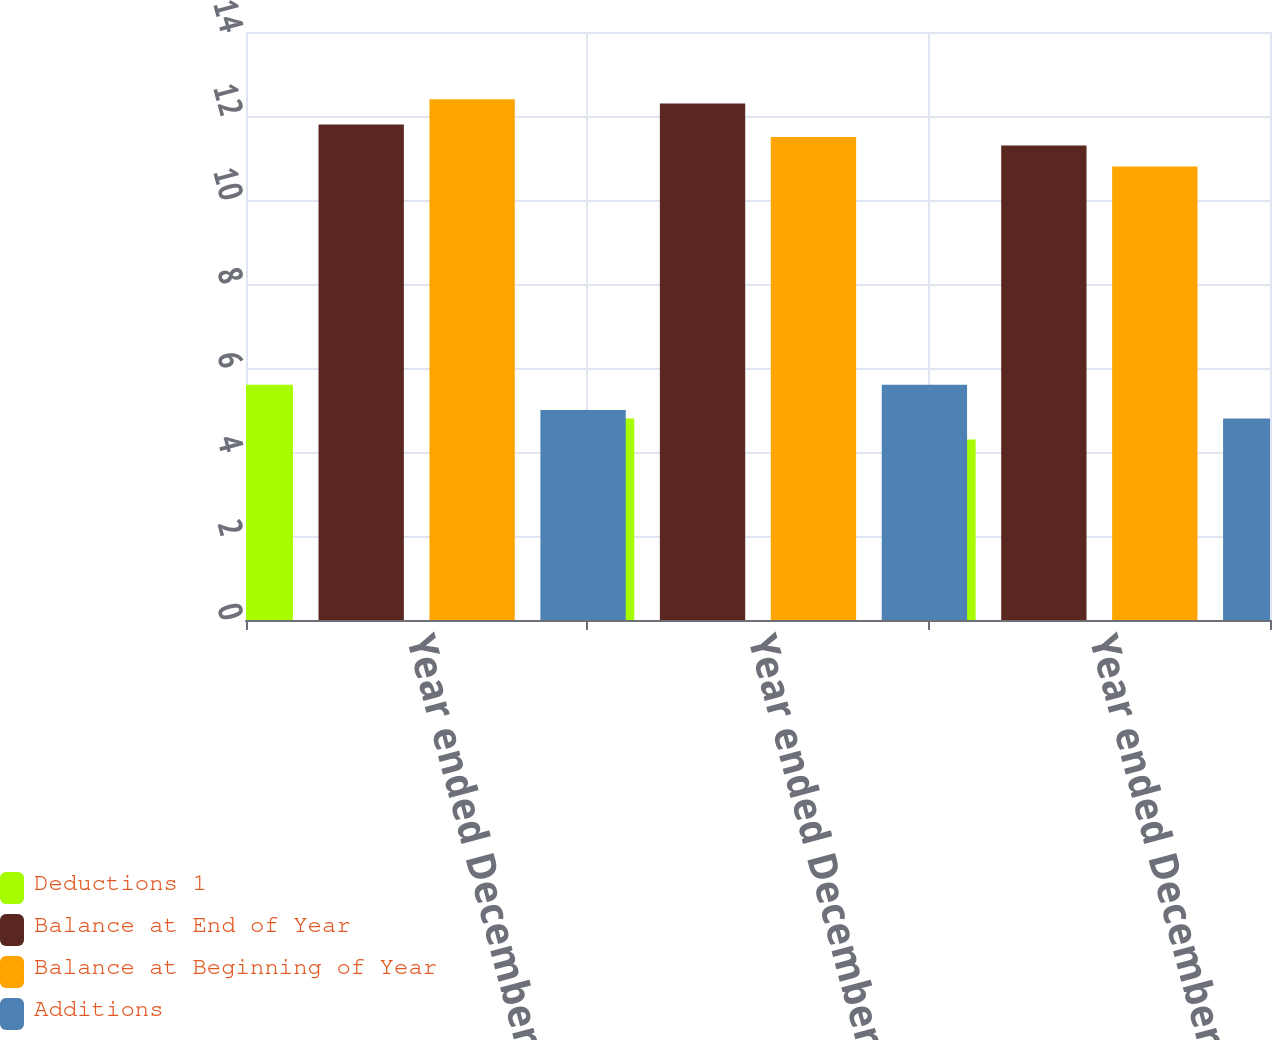<chart> <loc_0><loc_0><loc_500><loc_500><stacked_bar_chart><ecel><fcel>Year ended December 31 2012<fcel>Year ended December 31 2011<fcel>Year ended December 31 2010<nl><fcel>Deductions 1<fcel>5.6<fcel>4.8<fcel>4.3<nl><fcel>Balance at End of Year<fcel>11.8<fcel>12.3<fcel>11.3<nl><fcel>Balance at Beginning of Year<fcel>12.4<fcel>11.5<fcel>10.8<nl><fcel>Additions<fcel>5<fcel>5.6<fcel>4.8<nl></chart> 